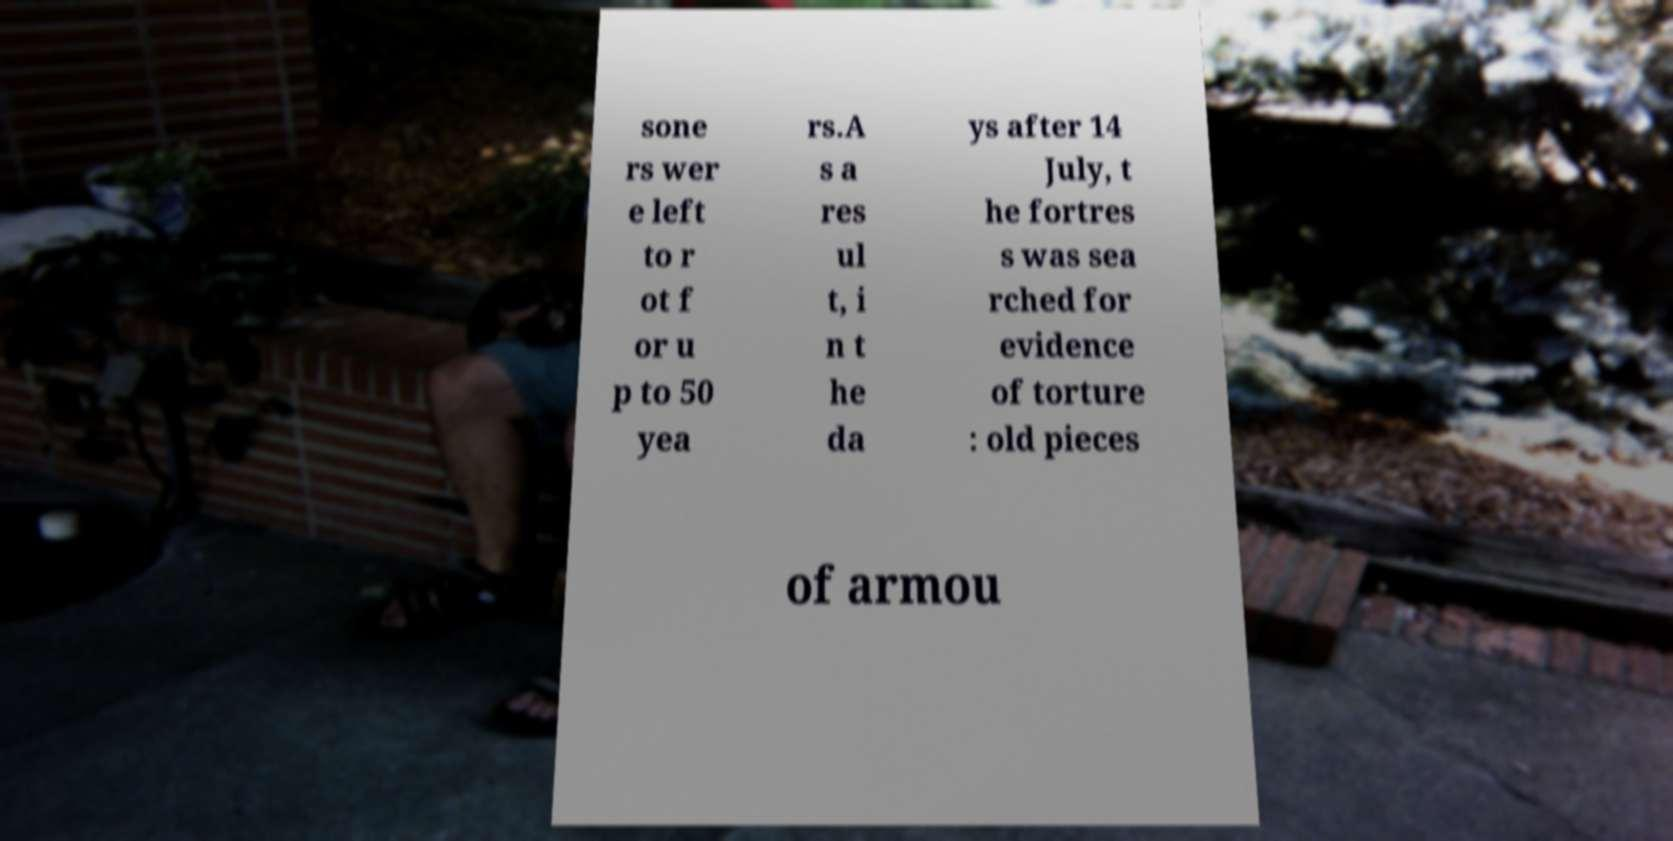What messages or text are displayed in this image? I need them in a readable, typed format. sone rs wer e left to r ot f or u p to 50 yea rs.A s a res ul t, i n t he da ys after 14 July, t he fortres s was sea rched for evidence of torture : old pieces of armou 